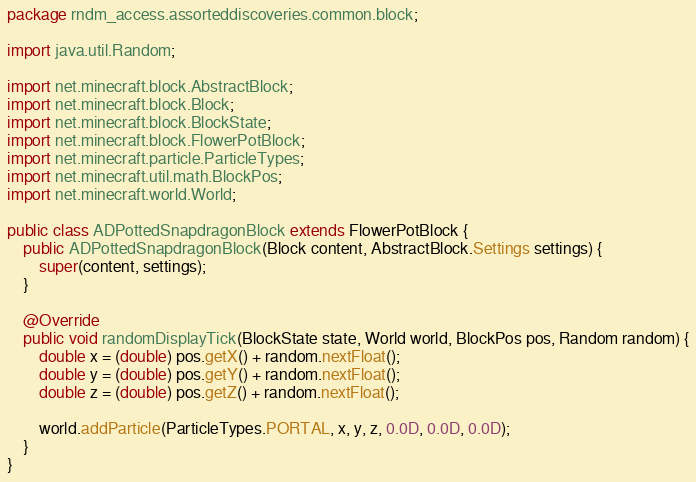Convert code to text. <code><loc_0><loc_0><loc_500><loc_500><_Java_>package rndm_access.assorteddiscoveries.common.block;

import java.util.Random;

import net.minecraft.block.AbstractBlock;
import net.minecraft.block.Block;
import net.minecraft.block.BlockState;
import net.minecraft.block.FlowerPotBlock;
import net.minecraft.particle.ParticleTypes;
import net.minecraft.util.math.BlockPos;
import net.minecraft.world.World;

public class ADPottedSnapdragonBlock extends FlowerPotBlock {
    public ADPottedSnapdragonBlock(Block content, AbstractBlock.Settings settings) {
        super(content, settings);
    }

    @Override
    public void randomDisplayTick(BlockState state, World world, BlockPos pos, Random random) {
        double x = (double) pos.getX() + random.nextFloat();
        double y = (double) pos.getY() + random.nextFloat();
        double z = (double) pos.getZ() + random.nextFloat();

        world.addParticle(ParticleTypes.PORTAL, x, y, z, 0.0D, 0.0D, 0.0D);
    }
}
</code> 